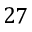<formula> <loc_0><loc_0><loc_500><loc_500>2 7</formula> 